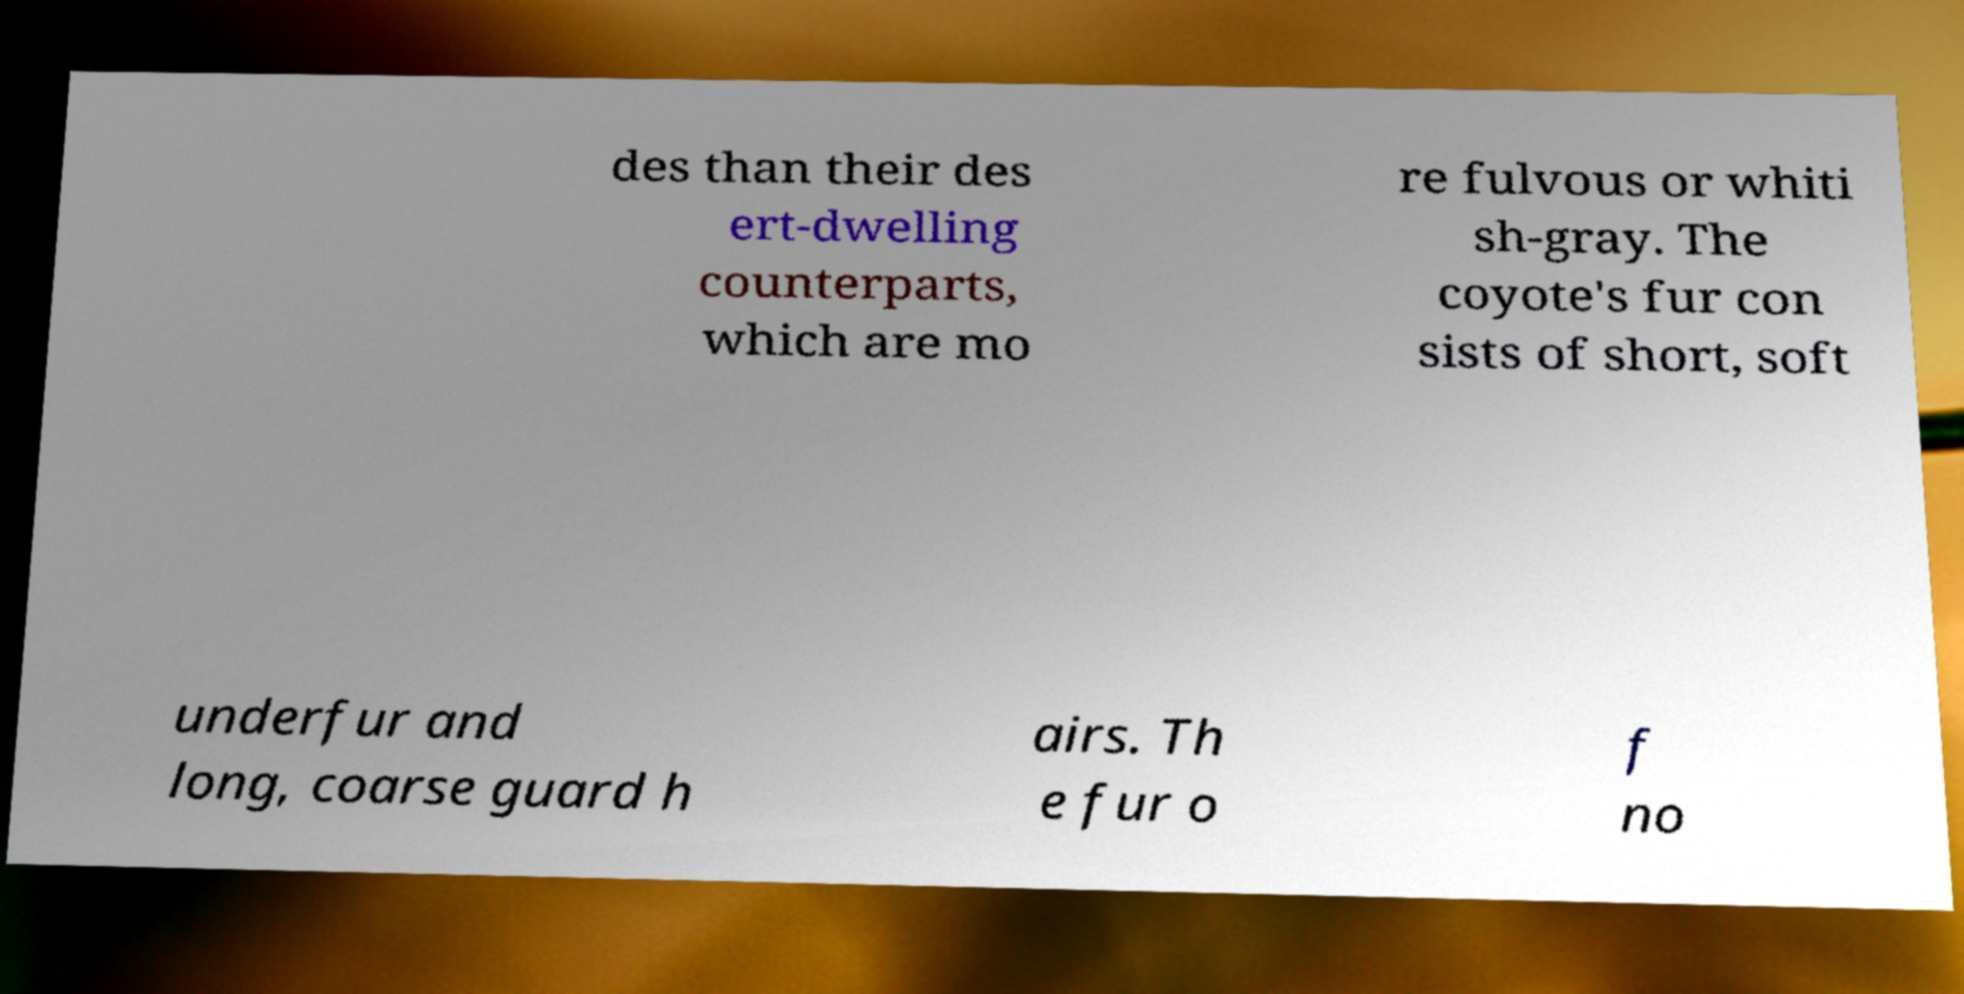For documentation purposes, I need the text within this image transcribed. Could you provide that? des than their des ert-dwelling counterparts, which are mo re fulvous or whiti sh-gray. The coyote's fur con sists of short, soft underfur and long, coarse guard h airs. Th e fur o f no 